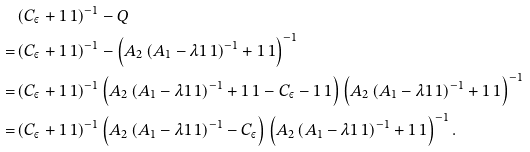Convert formula to latex. <formula><loc_0><loc_0><loc_500><loc_500>& \left ( C _ { \varepsilon } + 1 \, 1 \right ) ^ { - 1 } - Q \\ = & \left ( C _ { \varepsilon } + 1 \, 1 \right ) ^ { - 1 } - \left ( A _ { 2 } \left ( A _ { 1 } - \lambda 1 \, 1 \right ) ^ { - 1 } + 1 \, 1 \right ) ^ { - 1 } \\ = & \left ( C _ { \varepsilon } + 1 \, 1 \right ) ^ { - 1 } \left ( A _ { 2 } \left ( A _ { 1 } - \lambda 1 \, 1 \right ) ^ { - 1 } + 1 \, 1 - C _ { \varepsilon } - 1 \, 1 \right ) \left ( A _ { 2 } \left ( A _ { 1 } - \lambda 1 \, 1 \right ) ^ { - 1 } + 1 \, 1 \right ) ^ { - 1 } \\ = & \left ( C _ { \varepsilon } + 1 \, 1 \right ) ^ { - 1 } \left ( A _ { 2 } \left ( A _ { 1 } - \lambda 1 \, 1 \right ) ^ { - 1 } - C _ { \varepsilon } \right ) \left ( A _ { 2 } \left ( A _ { 1 } - \lambda 1 \, 1 \right ) ^ { - 1 } + 1 \, 1 \right ) ^ { - 1 } .</formula> 